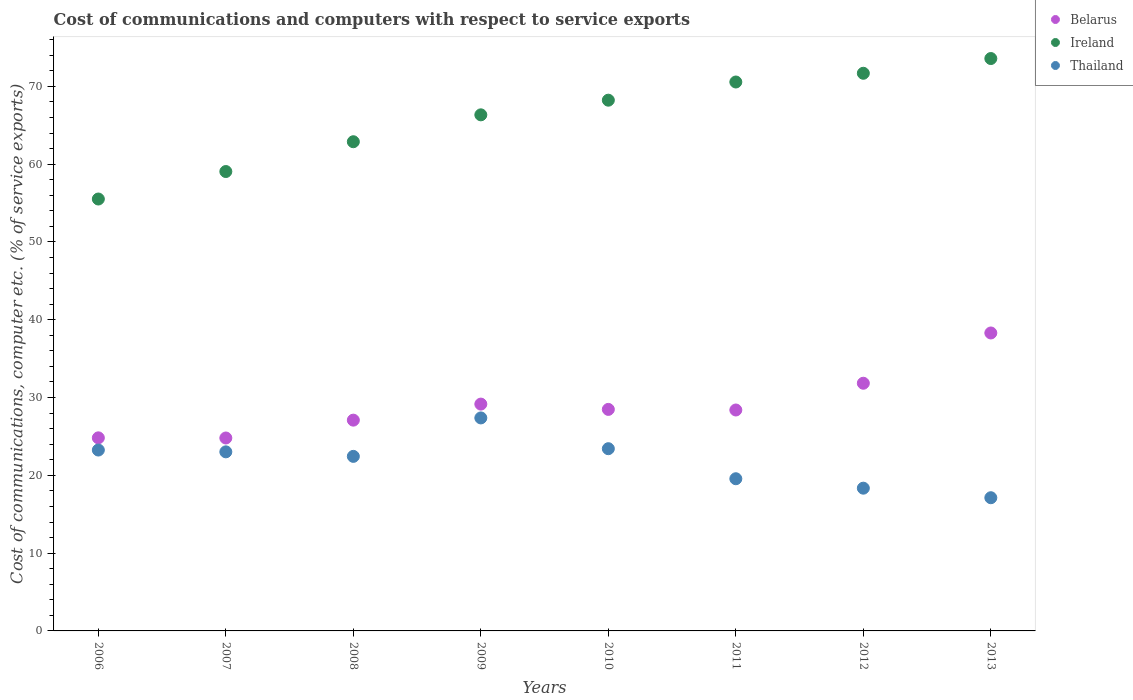What is the cost of communications and computers in Thailand in 2012?
Your answer should be very brief. 18.35. Across all years, what is the maximum cost of communications and computers in Thailand?
Give a very brief answer. 27.38. Across all years, what is the minimum cost of communications and computers in Thailand?
Provide a succinct answer. 17.12. In which year was the cost of communications and computers in Ireland maximum?
Keep it short and to the point. 2013. In which year was the cost of communications and computers in Thailand minimum?
Your answer should be very brief. 2013. What is the total cost of communications and computers in Belarus in the graph?
Give a very brief answer. 232.87. What is the difference between the cost of communications and computers in Ireland in 2006 and that in 2010?
Ensure brevity in your answer.  -12.7. What is the difference between the cost of communications and computers in Belarus in 2008 and the cost of communications and computers in Ireland in 2007?
Ensure brevity in your answer.  -31.96. What is the average cost of communications and computers in Ireland per year?
Your answer should be compact. 65.98. In the year 2011, what is the difference between the cost of communications and computers in Thailand and cost of communications and computers in Ireland?
Offer a very short reply. -50.99. What is the ratio of the cost of communications and computers in Ireland in 2012 to that in 2013?
Keep it short and to the point. 0.97. Is the cost of communications and computers in Belarus in 2008 less than that in 2011?
Provide a short and direct response. Yes. What is the difference between the highest and the second highest cost of communications and computers in Thailand?
Provide a succinct answer. 3.96. What is the difference between the highest and the lowest cost of communications and computers in Thailand?
Make the answer very short. 10.26. In how many years, is the cost of communications and computers in Thailand greater than the average cost of communications and computers in Thailand taken over all years?
Offer a very short reply. 5. Is the sum of the cost of communications and computers in Belarus in 2007 and 2012 greater than the maximum cost of communications and computers in Thailand across all years?
Provide a short and direct response. Yes. Is the cost of communications and computers in Belarus strictly less than the cost of communications and computers in Ireland over the years?
Offer a very short reply. Yes. How many years are there in the graph?
Ensure brevity in your answer.  8. Are the values on the major ticks of Y-axis written in scientific E-notation?
Make the answer very short. No. Does the graph contain any zero values?
Make the answer very short. No. Does the graph contain grids?
Make the answer very short. No. Where does the legend appear in the graph?
Your answer should be very brief. Top right. How many legend labels are there?
Your answer should be compact. 3. What is the title of the graph?
Ensure brevity in your answer.  Cost of communications and computers with respect to service exports. What is the label or title of the X-axis?
Keep it short and to the point. Years. What is the label or title of the Y-axis?
Offer a very short reply. Cost of communications, computer etc. (% of service exports). What is the Cost of communications, computer etc. (% of service exports) of Belarus in 2006?
Offer a terse response. 24.82. What is the Cost of communications, computer etc. (% of service exports) of Ireland in 2006?
Your answer should be compact. 55.52. What is the Cost of communications, computer etc. (% of service exports) of Thailand in 2006?
Make the answer very short. 23.25. What is the Cost of communications, computer etc. (% of service exports) of Belarus in 2007?
Offer a very short reply. 24.8. What is the Cost of communications, computer etc. (% of service exports) in Ireland in 2007?
Ensure brevity in your answer.  59.05. What is the Cost of communications, computer etc. (% of service exports) in Thailand in 2007?
Provide a succinct answer. 23.02. What is the Cost of communications, computer etc. (% of service exports) of Belarus in 2008?
Give a very brief answer. 27.09. What is the Cost of communications, computer etc. (% of service exports) in Ireland in 2008?
Offer a terse response. 62.88. What is the Cost of communications, computer etc. (% of service exports) of Thailand in 2008?
Keep it short and to the point. 22.44. What is the Cost of communications, computer etc. (% of service exports) in Belarus in 2009?
Your answer should be compact. 29.16. What is the Cost of communications, computer etc. (% of service exports) in Ireland in 2009?
Provide a short and direct response. 66.34. What is the Cost of communications, computer etc. (% of service exports) in Thailand in 2009?
Give a very brief answer. 27.38. What is the Cost of communications, computer etc. (% of service exports) of Belarus in 2010?
Provide a short and direct response. 28.47. What is the Cost of communications, computer etc. (% of service exports) of Ireland in 2010?
Provide a succinct answer. 68.22. What is the Cost of communications, computer etc. (% of service exports) of Thailand in 2010?
Make the answer very short. 23.42. What is the Cost of communications, computer etc. (% of service exports) of Belarus in 2011?
Offer a terse response. 28.4. What is the Cost of communications, computer etc. (% of service exports) of Ireland in 2011?
Your answer should be very brief. 70.56. What is the Cost of communications, computer etc. (% of service exports) of Thailand in 2011?
Provide a succinct answer. 19.56. What is the Cost of communications, computer etc. (% of service exports) in Belarus in 2012?
Give a very brief answer. 31.84. What is the Cost of communications, computer etc. (% of service exports) in Ireland in 2012?
Ensure brevity in your answer.  71.68. What is the Cost of communications, computer etc. (% of service exports) of Thailand in 2012?
Give a very brief answer. 18.35. What is the Cost of communications, computer etc. (% of service exports) in Belarus in 2013?
Provide a succinct answer. 38.3. What is the Cost of communications, computer etc. (% of service exports) in Ireland in 2013?
Your response must be concise. 73.57. What is the Cost of communications, computer etc. (% of service exports) in Thailand in 2013?
Provide a short and direct response. 17.12. Across all years, what is the maximum Cost of communications, computer etc. (% of service exports) in Belarus?
Ensure brevity in your answer.  38.3. Across all years, what is the maximum Cost of communications, computer etc. (% of service exports) of Ireland?
Your answer should be compact. 73.57. Across all years, what is the maximum Cost of communications, computer etc. (% of service exports) in Thailand?
Your answer should be very brief. 27.38. Across all years, what is the minimum Cost of communications, computer etc. (% of service exports) of Belarus?
Offer a terse response. 24.8. Across all years, what is the minimum Cost of communications, computer etc. (% of service exports) in Ireland?
Your answer should be very brief. 55.52. Across all years, what is the minimum Cost of communications, computer etc. (% of service exports) of Thailand?
Make the answer very short. 17.12. What is the total Cost of communications, computer etc. (% of service exports) of Belarus in the graph?
Make the answer very short. 232.87. What is the total Cost of communications, computer etc. (% of service exports) of Ireland in the graph?
Offer a very short reply. 527.8. What is the total Cost of communications, computer etc. (% of service exports) in Thailand in the graph?
Your answer should be very brief. 174.53. What is the difference between the Cost of communications, computer etc. (% of service exports) of Belarus in 2006 and that in 2007?
Give a very brief answer. 0.02. What is the difference between the Cost of communications, computer etc. (% of service exports) of Ireland in 2006 and that in 2007?
Offer a terse response. -3.53. What is the difference between the Cost of communications, computer etc. (% of service exports) in Thailand in 2006 and that in 2007?
Your answer should be compact. 0.23. What is the difference between the Cost of communications, computer etc. (% of service exports) in Belarus in 2006 and that in 2008?
Offer a terse response. -2.27. What is the difference between the Cost of communications, computer etc. (% of service exports) in Ireland in 2006 and that in 2008?
Keep it short and to the point. -7.36. What is the difference between the Cost of communications, computer etc. (% of service exports) of Thailand in 2006 and that in 2008?
Offer a very short reply. 0.81. What is the difference between the Cost of communications, computer etc. (% of service exports) of Belarus in 2006 and that in 2009?
Provide a succinct answer. -4.34. What is the difference between the Cost of communications, computer etc. (% of service exports) in Ireland in 2006 and that in 2009?
Ensure brevity in your answer.  -10.82. What is the difference between the Cost of communications, computer etc. (% of service exports) of Thailand in 2006 and that in 2009?
Your answer should be very brief. -4.13. What is the difference between the Cost of communications, computer etc. (% of service exports) in Belarus in 2006 and that in 2010?
Keep it short and to the point. -3.66. What is the difference between the Cost of communications, computer etc. (% of service exports) in Ireland in 2006 and that in 2010?
Keep it short and to the point. -12.7. What is the difference between the Cost of communications, computer etc. (% of service exports) of Thailand in 2006 and that in 2010?
Provide a succinct answer. -0.17. What is the difference between the Cost of communications, computer etc. (% of service exports) in Belarus in 2006 and that in 2011?
Give a very brief answer. -3.58. What is the difference between the Cost of communications, computer etc. (% of service exports) of Ireland in 2006 and that in 2011?
Offer a very short reply. -15.04. What is the difference between the Cost of communications, computer etc. (% of service exports) of Thailand in 2006 and that in 2011?
Your answer should be very brief. 3.69. What is the difference between the Cost of communications, computer etc. (% of service exports) of Belarus in 2006 and that in 2012?
Your response must be concise. -7.02. What is the difference between the Cost of communications, computer etc. (% of service exports) of Ireland in 2006 and that in 2012?
Provide a succinct answer. -16.16. What is the difference between the Cost of communications, computer etc. (% of service exports) in Thailand in 2006 and that in 2012?
Provide a short and direct response. 4.9. What is the difference between the Cost of communications, computer etc. (% of service exports) in Belarus in 2006 and that in 2013?
Your answer should be very brief. -13.48. What is the difference between the Cost of communications, computer etc. (% of service exports) of Ireland in 2006 and that in 2013?
Offer a terse response. -18.06. What is the difference between the Cost of communications, computer etc. (% of service exports) in Thailand in 2006 and that in 2013?
Offer a terse response. 6.13. What is the difference between the Cost of communications, computer etc. (% of service exports) of Belarus in 2007 and that in 2008?
Ensure brevity in your answer.  -2.29. What is the difference between the Cost of communications, computer etc. (% of service exports) in Ireland in 2007 and that in 2008?
Your answer should be compact. -3.83. What is the difference between the Cost of communications, computer etc. (% of service exports) of Thailand in 2007 and that in 2008?
Provide a short and direct response. 0.58. What is the difference between the Cost of communications, computer etc. (% of service exports) in Belarus in 2007 and that in 2009?
Provide a succinct answer. -4.36. What is the difference between the Cost of communications, computer etc. (% of service exports) in Ireland in 2007 and that in 2009?
Ensure brevity in your answer.  -7.29. What is the difference between the Cost of communications, computer etc. (% of service exports) of Thailand in 2007 and that in 2009?
Offer a very short reply. -4.36. What is the difference between the Cost of communications, computer etc. (% of service exports) of Belarus in 2007 and that in 2010?
Your answer should be very brief. -3.68. What is the difference between the Cost of communications, computer etc. (% of service exports) in Ireland in 2007 and that in 2010?
Provide a succinct answer. -9.17. What is the difference between the Cost of communications, computer etc. (% of service exports) of Thailand in 2007 and that in 2010?
Give a very brief answer. -0.4. What is the difference between the Cost of communications, computer etc. (% of service exports) of Belarus in 2007 and that in 2011?
Ensure brevity in your answer.  -3.6. What is the difference between the Cost of communications, computer etc. (% of service exports) in Ireland in 2007 and that in 2011?
Offer a terse response. -11.51. What is the difference between the Cost of communications, computer etc. (% of service exports) of Thailand in 2007 and that in 2011?
Offer a terse response. 3.46. What is the difference between the Cost of communications, computer etc. (% of service exports) in Belarus in 2007 and that in 2012?
Make the answer very short. -7.04. What is the difference between the Cost of communications, computer etc. (% of service exports) of Ireland in 2007 and that in 2012?
Your answer should be compact. -12.63. What is the difference between the Cost of communications, computer etc. (% of service exports) in Thailand in 2007 and that in 2012?
Provide a succinct answer. 4.67. What is the difference between the Cost of communications, computer etc. (% of service exports) in Belarus in 2007 and that in 2013?
Provide a short and direct response. -13.5. What is the difference between the Cost of communications, computer etc. (% of service exports) in Ireland in 2007 and that in 2013?
Ensure brevity in your answer.  -14.52. What is the difference between the Cost of communications, computer etc. (% of service exports) of Thailand in 2007 and that in 2013?
Keep it short and to the point. 5.9. What is the difference between the Cost of communications, computer etc. (% of service exports) of Belarus in 2008 and that in 2009?
Offer a very short reply. -2.06. What is the difference between the Cost of communications, computer etc. (% of service exports) in Ireland in 2008 and that in 2009?
Make the answer very short. -3.46. What is the difference between the Cost of communications, computer etc. (% of service exports) in Thailand in 2008 and that in 2009?
Ensure brevity in your answer.  -4.94. What is the difference between the Cost of communications, computer etc. (% of service exports) in Belarus in 2008 and that in 2010?
Provide a succinct answer. -1.38. What is the difference between the Cost of communications, computer etc. (% of service exports) of Ireland in 2008 and that in 2010?
Offer a very short reply. -5.34. What is the difference between the Cost of communications, computer etc. (% of service exports) of Thailand in 2008 and that in 2010?
Ensure brevity in your answer.  -0.99. What is the difference between the Cost of communications, computer etc. (% of service exports) of Belarus in 2008 and that in 2011?
Give a very brief answer. -1.3. What is the difference between the Cost of communications, computer etc. (% of service exports) in Ireland in 2008 and that in 2011?
Make the answer very short. -7.68. What is the difference between the Cost of communications, computer etc. (% of service exports) in Thailand in 2008 and that in 2011?
Your response must be concise. 2.87. What is the difference between the Cost of communications, computer etc. (% of service exports) in Belarus in 2008 and that in 2012?
Offer a terse response. -4.74. What is the difference between the Cost of communications, computer etc. (% of service exports) of Ireland in 2008 and that in 2012?
Offer a very short reply. -8.8. What is the difference between the Cost of communications, computer etc. (% of service exports) of Thailand in 2008 and that in 2012?
Your response must be concise. 4.09. What is the difference between the Cost of communications, computer etc. (% of service exports) in Belarus in 2008 and that in 2013?
Provide a succinct answer. -11.2. What is the difference between the Cost of communications, computer etc. (% of service exports) of Ireland in 2008 and that in 2013?
Your answer should be very brief. -10.69. What is the difference between the Cost of communications, computer etc. (% of service exports) of Thailand in 2008 and that in 2013?
Provide a short and direct response. 5.32. What is the difference between the Cost of communications, computer etc. (% of service exports) of Belarus in 2009 and that in 2010?
Your answer should be very brief. 0.68. What is the difference between the Cost of communications, computer etc. (% of service exports) of Ireland in 2009 and that in 2010?
Your answer should be very brief. -1.88. What is the difference between the Cost of communications, computer etc. (% of service exports) of Thailand in 2009 and that in 2010?
Your answer should be very brief. 3.96. What is the difference between the Cost of communications, computer etc. (% of service exports) of Belarus in 2009 and that in 2011?
Offer a terse response. 0.76. What is the difference between the Cost of communications, computer etc. (% of service exports) in Ireland in 2009 and that in 2011?
Offer a very short reply. -4.22. What is the difference between the Cost of communications, computer etc. (% of service exports) in Thailand in 2009 and that in 2011?
Your answer should be compact. 7.82. What is the difference between the Cost of communications, computer etc. (% of service exports) of Belarus in 2009 and that in 2012?
Offer a very short reply. -2.68. What is the difference between the Cost of communications, computer etc. (% of service exports) of Ireland in 2009 and that in 2012?
Offer a very short reply. -5.34. What is the difference between the Cost of communications, computer etc. (% of service exports) of Thailand in 2009 and that in 2012?
Your answer should be compact. 9.03. What is the difference between the Cost of communications, computer etc. (% of service exports) in Belarus in 2009 and that in 2013?
Provide a short and direct response. -9.14. What is the difference between the Cost of communications, computer etc. (% of service exports) of Ireland in 2009 and that in 2013?
Ensure brevity in your answer.  -7.24. What is the difference between the Cost of communications, computer etc. (% of service exports) of Thailand in 2009 and that in 2013?
Offer a very short reply. 10.26. What is the difference between the Cost of communications, computer etc. (% of service exports) of Belarus in 2010 and that in 2011?
Keep it short and to the point. 0.08. What is the difference between the Cost of communications, computer etc. (% of service exports) in Ireland in 2010 and that in 2011?
Provide a short and direct response. -2.34. What is the difference between the Cost of communications, computer etc. (% of service exports) of Thailand in 2010 and that in 2011?
Provide a succinct answer. 3.86. What is the difference between the Cost of communications, computer etc. (% of service exports) of Belarus in 2010 and that in 2012?
Give a very brief answer. -3.36. What is the difference between the Cost of communications, computer etc. (% of service exports) of Ireland in 2010 and that in 2012?
Your response must be concise. -3.46. What is the difference between the Cost of communications, computer etc. (% of service exports) of Thailand in 2010 and that in 2012?
Your answer should be compact. 5.07. What is the difference between the Cost of communications, computer etc. (% of service exports) in Belarus in 2010 and that in 2013?
Your response must be concise. -9.82. What is the difference between the Cost of communications, computer etc. (% of service exports) of Ireland in 2010 and that in 2013?
Ensure brevity in your answer.  -5.35. What is the difference between the Cost of communications, computer etc. (% of service exports) of Thailand in 2010 and that in 2013?
Provide a succinct answer. 6.3. What is the difference between the Cost of communications, computer etc. (% of service exports) in Belarus in 2011 and that in 2012?
Your answer should be compact. -3.44. What is the difference between the Cost of communications, computer etc. (% of service exports) of Ireland in 2011 and that in 2012?
Provide a succinct answer. -1.12. What is the difference between the Cost of communications, computer etc. (% of service exports) in Thailand in 2011 and that in 2012?
Provide a succinct answer. 1.21. What is the difference between the Cost of communications, computer etc. (% of service exports) of Belarus in 2011 and that in 2013?
Offer a very short reply. -9.9. What is the difference between the Cost of communications, computer etc. (% of service exports) in Ireland in 2011 and that in 2013?
Offer a terse response. -3.02. What is the difference between the Cost of communications, computer etc. (% of service exports) in Thailand in 2011 and that in 2013?
Offer a very short reply. 2.44. What is the difference between the Cost of communications, computer etc. (% of service exports) in Belarus in 2012 and that in 2013?
Make the answer very short. -6.46. What is the difference between the Cost of communications, computer etc. (% of service exports) of Ireland in 2012 and that in 2013?
Your answer should be very brief. -1.89. What is the difference between the Cost of communications, computer etc. (% of service exports) in Thailand in 2012 and that in 2013?
Ensure brevity in your answer.  1.23. What is the difference between the Cost of communications, computer etc. (% of service exports) of Belarus in 2006 and the Cost of communications, computer etc. (% of service exports) of Ireland in 2007?
Offer a terse response. -34.23. What is the difference between the Cost of communications, computer etc. (% of service exports) of Belarus in 2006 and the Cost of communications, computer etc. (% of service exports) of Thailand in 2007?
Provide a short and direct response. 1.8. What is the difference between the Cost of communications, computer etc. (% of service exports) in Ireland in 2006 and the Cost of communications, computer etc. (% of service exports) in Thailand in 2007?
Ensure brevity in your answer.  32.5. What is the difference between the Cost of communications, computer etc. (% of service exports) in Belarus in 2006 and the Cost of communications, computer etc. (% of service exports) in Ireland in 2008?
Your response must be concise. -38.06. What is the difference between the Cost of communications, computer etc. (% of service exports) in Belarus in 2006 and the Cost of communications, computer etc. (% of service exports) in Thailand in 2008?
Your answer should be very brief. 2.38. What is the difference between the Cost of communications, computer etc. (% of service exports) of Ireland in 2006 and the Cost of communications, computer etc. (% of service exports) of Thailand in 2008?
Keep it short and to the point. 33.08. What is the difference between the Cost of communications, computer etc. (% of service exports) in Belarus in 2006 and the Cost of communications, computer etc. (% of service exports) in Ireland in 2009?
Give a very brief answer. -41.52. What is the difference between the Cost of communications, computer etc. (% of service exports) in Belarus in 2006 and the Cost of communications, computer etc. (% of service exports) in Thailand in 2009?
Your answer should be very brief. -2.56. What is the difference between the Cost of communications, computer etc. (% of service exports) of Ireland in 2006 and the Cost of communications, computer etc. (% of service exports) of Thailand in 2009?
Provide a short and direct response. 28.14. What is the difference between the Cost of communications, computer etc. (% of service exports) in Belarus in 2006 and the Cost of communications, computer etc. (% of service exports) in Ireland in 2010?
Your response must be concise. -43.4. What is the difference between the Cost of communications, computer etc. (% of service exports) in Belarus in 2006 and the Cost of communications, computer etc. (% of service exports) in Thailand in 2010?
Give a very brief answer. 1.4. What is the difference between the Cost of communications, computer etc. (% of service exports) in Ireland in 2006 and the Cost of communications, computer etc. (% of service exports) in Thailand in 2010?
Provide a short and direct response. 32.09. What is the difference between the Cost of communications, computer etc. (% of service exports) of Belarus in 2006 and the Cost of communications, computer etc. (% of service exports) of Ireland in 2011?
Provide a short and direct response. -45.74. What is the difference between the Cost of communications, computer etc. (% of service exports) of Belarus in 2006 and the Cost of communications, computer etc. (% of service exports) of Thailand in 2011?
Your response must be concise. 5.26. What is the difference between the Cost of communications, computer etc. (% of service exports) of Ireland in 2006 and the Cost of communications, computer etc. (% of service exports) of Thailand in 2011?
Your answer should be compact. 35.95. What is the difference between the Cost of communications, computer etc. (% of service exports) of Belarus in 2006 and the Cost of communications, computer etc. (% of service exports) of Ireland in 2012?
Provide a short and direct response. -46.86. What is the difference between the Cost of communications, computer etc. (% of service exports) of Belarus in 2006 and the Cost of communications, computer etc. (% of service exports) of Thailand in 2012?
Give a very brief answer. 6.47. What is the difference between the Cost of communications, computer etc. (% of service exports) in Ireland in 2006 and the Cost of communications, computer etc. (% of service exports) in Thailand in 2012?
Make the answer very short. 37.17. What is the difference between the Cost of communications, computer etc. (% of service exports) in Belarus in 2006 and the Cost of communications, computer etc. (% of service exports) in Ireland in 2013?
Offer a terse response. -48.75. What is the difference between the Cost of communications, computer etc. (% of service exports) of Belarus in 2006 and the Cost of communications, computer etc. (% of service exports) of Thailand in 2013?
Provide a short and direct response. 7.7. What is the difference between the Cost of communications, computer etc. (% of service exports) of Ireland in 2006 and the Cost of communications, computer etc. (% of service exports) of Thailand in 2013?
Your answer should be very brief. 38.39. What is the difference between the Cost of communications, computer etc. (% of service exports) in Belarus in 2007 and the Cost of communications, computer etc. (% of service exports) in Ireland in 2008?
Provide a short and direct response. -38.08. What is the difference between the Cost of communications, computer etc. (% of service exports) in Belarus in 2007 and the Cost of communications, computer etc. (% of service exports) in Thailand in 2008?
Your response must be concise. 2.36. What is the difference between the Cost of communications, computer etc. (% of service exports) of Ireland in 2007 and the Cost of communications, computer etc. (% of service exports) of Thailand in 2008?
Provide a short and direct response. 36.61. What is the difference between the Cost of communications, computer etc. (% of service exports) in Belarus in 2007 and the Cost of communications, computer etc. (% of service exports) in Ireland in 2009?
Provide a succinct answer. -41.54. What is the difference between the Cost of communications, computer etc. (% of service exports) of Belarus in 2007 and the Cost of communications, computer etc. (% of service exports) of Thailand in 2009?
Your answer should be compact. -2.58. What is the difference between the Cost of communications, computer etc. (% of service exports) in Ireland in 2007 and the Cost of communications, computer etc. (% of service exports) in Thailand in 2009?
Keep it short and to the point. 31.67. What is the difference between the Cost of communications, computer etc. (% of service exports) of Belarus in 2007 and the Cost of communications, computer etc. (% of service exports) of Ireland in 2010?
Give a very brief answer. -43.42. What is the difference between the Cost of communications, computer etc. (% of service exports) in Belarus in 2007 and the Cost of communications, computer etc. (% of service exports) in Thailand in 2010?
Your answer should be very brief. 1.38. What is the difference between the Cost of communications, computer etc. (% of service exports) in Ireland in 2007 and the Cost of communications, computer etc. (% of service exports) in Thailand in 2010?
Give a very brief answer. 35.63. What is the difference between the Cost of communications, computer etc. (% of service exports) in Belarus in 2007 and the Cost of communications, computer etc. (% of service exports) in Ireland in 2011?
Provide a succinct answer. -45.76. What is the difference between the Cost of communications, computer etc. (% of service exports) in Belarus in 2007 and the Cost of communications, computer etc. (% of service exports) in Thailand in 2011?
Your answer should be compact. 5.24. What is the difference between the Cost of communications, computer etc. (% of service exports) of Ireland in 2007 and the Cost of communications, computer etc. (% of service exports) of Thailand in 2011?
Offer a very short reply. 39.49. What is the difference between the Cost of communications, computer etc. (% of service exports) in Belarus in 2007 and the Cost of communications, computer etc. (% of service exports) in Ireland in 2012?
Your response must be concise. -46.88. What is the difference between the Cost of communications, computer etc. (% of service exports) in Belarus in 2007 and the Cost of communications, computer etc. (% of service exports) in Thailand in 2012?
Make the answer very short. 6.45. What is the difference between the Cost of communications, computer etc. (% of service exports) in Ireland in 2007 and the Cost of communications, computer etc. (% of service exports) in Thailand in 2012?
Your response must be concise. 40.7. What is the difference between the Cost of communications, computer etc. (% of service exports) in Belarus in 2007 and the Cost of communications, computer etc. (% of service exports) in Ireland in 2013?
Offer a very short reply. -48.77. What is the difference between the Cost of communications, computer etc. (% of service exports) in Belarus in 2007 and the Cost of communications, computer etc. (% of service exports) in Thailand in 2013?
Your answer should be very brief. 7.68. What is the difference between the Cost of communications, computer etc. (% of service exports) in Ireland in 2007 and the Cost of communications, computer etc. (% of service exports) in Thailand in 2013?
Ensure brevity in your answer.  41.93. What is the difference between the Cost of communications, computer etc. (% of service exports) in Belarus in 2008 and the Cost of communications, computer etc. (% of service exports) in Ireland in 2009?
Offer a terse response. -39.24. What is the difference between the Cost of communications, computer etc. (% of service exports) in Belarus in 2008 and the Cost of communications, computer etc. (% of service exports) in Thailand in 2009?
Ensure brevity in your answer.  -0.29. What is the difference between the Cost of communications, computer etc. (% of service exports) of Ireland in 2008 and the Cost of communications, computer etc. (% of service exports) of Thailand in 2009?
Make the answer very short. 35.5. What is the difference between the Cost of communications, computer etc. (% of service exports) in Belarus in 2008 and the Cost of communications, computer etc. (% of service exports) in Ireland in 2010?
Provide a short and direct response. -41.13. What is the difference between the Cost of communications, computer etc. (% of service exports) of Belarus in 2008 and the Cost of communications, computer etc. (% of service exports) of Thailand in 2010?
Your answer should be compact. 3.67. What is the difference between the Cost of communications, computer etc. (% of service exports) of Ireland in 2008 and the Cost of communications, computer etc. (% of service exports) of Thailand in 2010?
Your response must be concise. 39.46. What is the difference between the Cost of communications, computer etc. (% of service exports) of Belarus in 2008 and the Cost of communications, computer etc. (% of service exports) of Ireland in 2011?
Give a very brief answer. -43.46. What is the difference between the Cost of communications, computer etc. (% of service exports) of Belarus in 2008 and the Cost of communications, computer etc. (% of service exports) of Thailand in 2011?
Provide a short and direct response. 7.53. What is the difference between the Cost of communications, computer etc. (% of service exports) of Ireland in 2008 and the Cost of communications, computer etc. (% of service exports) of Thailand in 2011?
Your answer should be very brief. 43.32. What is the difference between the Cost of communications, computer etc. (% of service exports) in Belarus in 2008 and the Cost of communications, computer etc. (% of service exports) in Ireland in 2012?
Your answer should be very brief. -44.59. What is the difference between the Cost of communications, computer etc. (% of service exports) of Belarus in 2008 and the Cost of communications, computer etc. (% of service exports) of Thailand in 2012?
Ensure brevity in your answer.  8.75. What is the difference between the Cost of communications, computer etc. (% of service exports) in Ireland in 2008 and the Cost of communications, computer etc. (% of service exports) in Thailand in 2012?
Give a very brief answer. 44.53. What is the difference between the Cost of communications, computer etc. (% of service exports) of Belarus in 2008 and the Cost of communications, computer etc. (% of service exports) of Ireland in 2013?
Offer a terse response. -46.48. What is the difference between the Cost of communications, computer etc. (% of service exports) of Belarus in 2008 and the Cost of communications, computer etc. (% of service exports) of Thailand in 2013?
Provide a short and direct response. 9.97. What is the difference between the Cost of communications, computer etc. (% of service exports) in Ireland in 2008 and the Cost of communications, computer etc. (% of service exports) in Thailand in 2013?
Make the answer very short. 45.76. What is the difference between the Cost of communications, computer etc. (% of service exports) in Belarus in 2009 and the Cost of communications, computer etc. (% of service exports) in Ireland in 2010?
Give a very brief answer. -39.06. What is the difference between the Cost of communications, computer etc. (% of service exports) of Belarus in 2009 and the Cost of communications, computer etc. (% of service exports) of Thailand in 2010?
Keep it short and to the point. 5.73. What is the difference between the Cost of communications, computer etc. (% of service exports) of Ireland in 2009 and the Cost of communications, computer etc. (% of service exports) of Thailand in 2010?
Make the answer very short. 42.91. What is the difference between the Cost of communications, computer etc. (% of service exports) in Belarus in 2009 and the Cost of communications, computer etc. (% of service exports) in Ireland in 2011?
Your answer should be very brief. -41.4. What is the difference between the Cost of communications, computer etc. (% of service exports) in Belarus in 2009 and the Cost of communications, computer etc. (% of service exports) in Thailand in 2011?
Your answer should be compact. 9.59. What is the difference between the Cost of communications, computer etc. (% of service exports) in Ireland in 2009 and the Cost of communications, computer etc. (% of service exports) in Thailand in 2011?
Provide a short and direct response. 46.77. What is the difference between the Cost of communications, computer etc. (% of service exports) of Belarus in 2009 and the Cost of communications, computer etc. (% of service exports) of Ireland in 2012?
Give a very brief answer. -42.52. What is the difference between the Cost of communications, computer etc. (% of service exports) in Belarus in 2009 and the Cost of communications, computer etc. (% of service exports) in Thailand in 2012?
Your answer should be compact. 10.81. What is the difference between the Cost of communications, computer etc. (% of service exports) in Ireland in 2009 and the Cost of communications, computer etc. (% of service exports) in Thailand in 2012?
Make the answer very short. 47.99. What is the difference between the Cost of communications, computer etc. (% of service exports) of Belarus in 2009 and the Cost of communications, computer etc. (% of service exports) of Ireland in 2013?
Make the answer very short. -44.42. What is the difference between the Cost of communications, computer etc. (% of service exports) in Belarus in 2009 and the Cost of communications, computer etc. (% of service exports) in Thailand in 2013?
Offer a terse response. 12.03. What is the difference between the Cost of communications, computer etc. (% of service exports) in Ireland in 2009 and the Cost of communications, computer etc. (% of service exports) in Thailand in 2013?
Offer a terse response. 49.21. What is the difference between the Cost of communications, computer etc. (% of service exports) of Belarus in 2010 and the Cost of communications, computer etc. (% of service exports) of Ireland in 2011?
Ensure brevity in your answer.  -42.08. What is the difference between the Cost of communications, computer etc. (% of service exports) in Belarus in 2010 and the Cost of communications, computer etc. (% of service exports) in Thailand in 2011?
Give a very brief answer. 8.91. What is the difference between the Cost of communications, computer etc. (% of service exports) of Ireland in 2010 and the Cost of communications, computer etc. (% of service exports) of Thailand in 2011?
Provide a short and direct response. 48.66. What is the difference between the Cost of communications, computer etc. (% of service exports) in Belarus in 2010 and the Cost of communications, computer etc. (% of service exports) in Ireland in 2012?
Provide a short and direct response. -43.2. What is the difference between the Cost of communications, computer etc. (% of service exports) in Belarus in 2010 and the Cost of communications, computer etc. (% of service exports) in Thailand in 2012?
Your answer should be compact. 10.13. What is the difference between the Cost of communications, computer etc. (% of service exports) of Ireland in 2010 and the Cost of communications, computer etc. (% of service exports) of Thailand in 2012?
Provide a short and direct response. 49.87. What is the difference between the Cost of communications, computer etc. (% of service exports) in Belarus in 2010 and the Cost of communications, computer etc. (% of service exports) in Ireland in 2013?
Keep it short and to the point. -45.1. What is the difference between the Cost of communications, computer etc. (% of service exports) of Belarus in 2010 and the Cost of communications, computer etc. (% of service exports) of Thailand in 2013?
Give a very brief answer. 11.35. What is the difference between the Cost of communications, computer etc. (% of service exports) of Ireland in 2010 and the Cost of communications, computer etc. (% of service exports) of Thailand in 2013?
Ensure brevity in your answer.  51.1. What is the difference between the Cost of communications, computer etc. (% of service exports) in Belarus in 2011 and the Cost of communications, computer etc. (% of service exports) in Ireland in 2012?
Provide a short and direct response. -43.28. What is the difference between the Cost of communications, computer etc. (% of service exports) in Belarus in 2011 and the Cost of communications, computer etc. (% of service exports) in Thailand in 2012?
Offer a terse response. 10.05. What is the difference between the Cost of communications, computer etc. (% of service exports) in Ireland in 2011 and the Cost of communications, computer etc. (% of service exports) in Thailand in 2012?
Give a very brief answer. 52.21. What is the difference between the Cost of communications, computer etc. (% of service exports) of Belarus in 2011 and the Cost of communications, computer etc. (% of service exports) of Ireland in 2013?
Offer a terse response. -45.18. What is the difference between the Cost of communications, computer etc. (% of service exports) in Belarus in 2011 and the Cost of communications, computer etc. (% of service exports) in Thailand in 2013?
Provide a succinct answer. 11.28. What is the difference between the Cost of communications, computer etc. (% of service exports) in Ireland in 2011 and the Cost of communications, computer etc. (% of service exports) in Thailand in 2013?
Your answer should be very brief. 53.44. What is the difference between the Cost of communications, computer etc. (% of service exports) of Belarus in 2012 and the Cost of communications, computer etc. (% of service exports) of Ireland in 2013?
Keep it short and to the point. -41.74. What is the difference between the Cost of communications, computer etc. (% of service exports) in Belarus in 2012 and the Cost of communications, computer etc. (% of service exports) in Thailand in 2013?
Your response must be concise. 14.72. What is the difference between the Cost of communications, computer etc. (% of service exports) in Ireland in 2012 and the Cost of communications, computer etc. (% of service exports) in Thailand in 2013?
Offer a very short reply. 54.56. What is the average Cost of communications, computer etc. (% of service exports) of Belarus per year?
Give a very brief answer. 29.11. What is the average Cost of communications, computer etc. (% of service exports) in Ireland per year?
Offer a very short reply. 65.98. What is the average Cost of communications, computer etc. (% of service exports) of Thailand per year?
Make the answer very short. 21.82. In the year 2006, what is the difference between the Cost of communications, computer etc. (% of service exports) in Belarus and Cost of communications, computer etc. (% of service exports) in Ireland?
Offer a very short reply. -30.7. In the year 2006, what is the difference between the Cost of communications, computer etc. (% of service exports) in Belarus and Cost of communications, computer etc. (% of service exports) in Thailand?
Your answer should be compact. 1.57. In the year 2006, what is the difference between the Cost of communications, computer etc. (% of service exports) in Ireland and Cost of communications, computer etc. (% of service exports) in Thailand?
Your response must be concise. 32.27. In the year 2007, what is the difference between the Cost of communications, computer etc. (% of service exports) of Belarus and Cost of communications, computer etc. (% of service exports) of Ireland?
Provide a short and direct response. -34.25. In the year 2007, what is the difference between the Cost of communications, computer etc. (% of service exports) of Belarus and Cost of communications, computer etc. (% of service exports) of Thailand?
Your answer should be very brief. 1.78. In the year 2007, what is the difference between the Cost of communications, computer etc. (% of service exports) of Ireland and Cost of communications, computer etc. (% of service exports) of Thailand?
Provide a short and direct response. 36.03. In the year 2008, what is the difference between the Cost of communications, computer etc. (% of service exports) of Belarus and Cost of communications, computer etc. (% of service exports) of Ireland?
Offer a terse response. -35.79. In the year 2008, what is the difference between the Cost of communications, computer etc. (% of service exports) in Belarus and Cost of communications, computer etc. (% of service exports) in Thailand?
Offer a very short reply. 4.66. In the year 2008, what is the difference between the Cost of communications, computer etc. (% of service exports) in Ireland and Cost of communications, computer etc. (% of service exports) in Thailand?
Offer a very short reply. 40.44. In the year 2009, what is the difference between the Cost of communications, computer etc. (% of service exports) in Belarus and Cost of communications, computer etc. (% of service exports) in Ireland?
Provide a short and direct response. -37.18. In the year 2009, what is the difference between the Cost of communications, computer etc. (% of service exports) in Belarus and Cost of communications, computer etc. (% of service exports) in Thailand?
Your answer should be compact. 1.78. In the year 2009, what is the difference between the Cost of communications, computer etc. (% of service exports) of Ireland and Cost of communications, computer etc. (% of service exports) of Thailand?
Your answer should be compact. 38.96. In the year 2010, what is the difference between the Cost of communications, computer etc. (% of service exports) of Belarus and Cost of communications, computer etc. (% of service exports) of Ireland?
Your answer should be very brief. -39.74. In the year 2010, what is the difference between the Cost of communications, computer etc. (% of service exports) of Belarus and Cost of communications, computer etc. (% of service exports) of Thailand?
Your answer should be very brief. 5.05. In the year 2010, what is the difference between the Cost of communications, computer etc. (% of service exports) of Ireland and Cost of communications, computer etc. (% of service exports) of Thailand?
Offer a very short reply. 44.8. In the year 2011, what is the difference between the Cost of communications, computer etc. (% of service exports) in Belarus and Cost of communications, computer etc. (% of service exports) in Ireland?
Your answer should be compact. -42.16. In the year 2011, what is the difference between the Cost of communications, computer etc. (% of service exports) in Belarus and Cost of communications, computer etc. (% of service exports) in Thailand?
Make the answer very short. 8.84. In the year 2011, what is the difference between the Cost of communications, computer etc. (% of service exports) in Ireland and Cost of communications, computer etc. (% of service exports) in Thailand?
Provide a short and direct response. 50.99. In the year 2012, what is the difference between the Cost of communications, computer etc. (% of service exports) in Belarus and Cost of communications, computer etc. (% of service exports) in Ireland?
Offer a terse response. -39.84. In the year 2012, what is the difference between the Cost of communications, computer etc. (% of service exports) in Belarus and Cost of communications, computer etc. (% of service exports) in Thailand?
Provide a short and direct response. 13.49. In the year 2012, what is the difference between the Cost of communications, computer etc. (% of service exports) in Ireland and Cost of communications, computer etc. (% of service exports) in Thailand?
Your answer should be compact. 53.33. In the year 2013, what is the difference between the Cost of communications, computer etc. (% of service exports) in Belarus and Cost of communications, computer etc. (% of service exports) in Ireland?
Your answer should be compact. -35.28. In the year 2013, what is the difference between the Cost of communications, computer etc. (% of service exports) of Belarus and Cost of communications, computer etc. (% of service exports) of Thailand?
Make the answer very short. 21.18. In the year 2013, what is the difference between the Cost of communications, computer etc. (% of service exports) of Ireland and Cost of communications, computer etc. (% of service exports) of Thailand?
Your response must be concise. 56.45. What is the ratio of the Cost of communications, computer etc. (% of service exports) of Belarus in 2006 to that in 2007?
Provide a succinct answer. 1. What is the ratio of the Cost of communications, computer etc. (% of service exports) of Ireland in 2006 to that in 2007?
Ensure brevity in your answer.  0.94. What is the ratio of the Cost of communications, computer etc. (% of service exports) in Thailand in 2006 to that in 2007?
Provide a short and direct response. 1.01. What is the ratio of the Cost of communications, computer etc. (% of service exports) in Belarus in 2006 to that in 2008?
Keep it short and to the point. 0.92. What is the ratio of the Cost of communications, computer etc. (% of service exports) of Ireland in 2006 to that in 2008?
Offer a very short reply. 0.88. What is the ratio of the Cost of communications, computer etc. (% of service exports) in Thailand in 2006 to that in 2008?
Keep it short and to the point. 1.04. What is the ratio of the Cost of communications, computer etc. (% of service exports) of Belarus in 2006 to that in 2009?
Your answer should be compact. 0.85. What is the ratio of the Cost of communications, computer etc. (% of service exports) in Ireland in 2006 to that in 2009?
Offer a very short reply. 0.84. What is the ratio of the Cost of communications, computer etc. (% of service exports) of Thailand in 2006 to that in 2009?
Keep it short and to the point. 0.85. What is the ratio of the Cost of communications, computer etc. (% of service exports) of Belarus in 2006 to that in 2010?
Make the answer very short. 0.87. What is the ratio of the Cost of communications, computer etc. (% of service exports) in Ireland in 2006 to that in 2010?
Offer a terse response. 0.81. What is the ratio of the Cost of communications, computer etc. (% of service exports) in Thailand in 2006 to that in 2010?
Keep it short and to the point. 0.99. What is the ratio of the Cost of communications, computer etc. (% of service exports) in Belarus in 2006 to that in 2011?
Your answer should be compact. 0.87. What is the ratio of the Cost of communications, computer etc. (% of service exports) of Ireland in 2006 to that in 2011?
Ensure brevity in your answer.  0.79. What is the ratio of the Cost of communications, computer etc. (% of service exports) of Thailand in 2006 to that in 2011?
Offer a terse response. 1.19. What is the ratio of the Cost of communications, computer etc. (% of service exports) of Belarus in 2006 to that in 2012?
Your answer should be very brief. 0.78. What is the ratio of the Cost of communications, computer etc. (% of service exports) of Ireland in 2006 to that in 2012?
Ensure brevity in your answer.  0.77. What is the ratio of the Cost of communications, computer etc. (% of service exports) in Thailand in 2006 to that in 2012?
Make the answer very short. 1.27. What is the ratio of the Cost of communications, computer etc. (% of service exports) of Belarus in 2006 to that in 2013?
Your response must be concise. 0.65. What is the ratio of the Cost of communications, computer etc. (% of service exports) in Ireland in 2006 to that in 2013?
Ensure brevity in your answer.  0.75. What is the ratio of the Cost of communications, computer etc. (% of service exports) in Thailand in 2006 to that in 2013?
Your response must be concise. 1.36. What is the ratio of the Cost of communications, computer etc. (% of service exports) in Belarus in 2007 to that in 2008?
Keep it short and to the point. 0.92. What is the ratio of the Cost of communications, computer etc. (% of service exports) in Ireland in 2007 to that in 2008?
Your response must be concise. 0.94. What is the ratio of the Cost of communications, computer etc. (% of service exports) of Thailand in 2007 to that in 2008?
Ensure brevity in your answer.  1.03. What is the ratio of the Cost of communications, computer etc. (% of service exports) in Belarus in 2007 to that in 2009?
Provide a succinct answer. 0.85. What is the ratio of the Cost of communications, computer etc. (% of service exports) in Ireland in 2007 to that in 2009?
Your answer should be compact. 0.89. What is the ratio of the Cost of communications, computer etc. (% of service exports) of Thailand in 2007 to that in 2009?
Your answer should be compact. 0.84. What is the ratio of the Cost of communications, computer etc. (% of service exports) of Belarus in 2007 to that in 2010?
Your response must be concise. 0.87. What is the ratio of the Cost of communications, computer etc. (% of service exports) of Ireland in 2007 to that in 2010?
Provide a succinct answer. 0.87. What is the ratio of the Cost of communications, computer etc. (% of service exports) of Thailand in 2007 to that in 2010?
Your response must be concise. 0.98. What is the ratio of the Cost of communications, computer etc. (% of service exports) in Belarus in 2007 to that in 2011?
Ensure brevity in your answer.  0.87. What is the ratio of the Cost of communications, computer etc. (% of service exports) in Ireland in 2007 to that in 2011?
Make the answer very short. 0.84. What is the ratio of the Cost of communications, computer etc. (% of service exports) in Thailand in 2007 to that in 2011?
Ensure brevity in your answer.  1.18. What is the ratio of the Cost of communications, computer etc. (% of service exports) in Belarus in 2007 to that in 2012?
Your answer should be very brief. 0.78. What is the ratio of the Cost of communications, computer etc. (% of service exports) of Ireland in 2007 to that in 2012?
Offer a very short reply. 0.82. What is the ratio of the Cost of communications, computer etc. (% of service exports) in Thailand in 2007 to that in 2012?
Your answer should be very brief. 1.25. What is the ratio of the Cost of communications, computer etc. (% of service exports) in Belarus in 2007 to that in 2013?
Your answer should be compact. 0.65. What is the ratio of the Cost of communications, computer etc. (% of service exports) in Ireland in 2007 to that in 2013?
Your response must be concise. 0.8. What is the ratio of the Cost of communications, computer etc. (% of service exports) of Thailand in 2007 to that in 2013?
Make the answer very short. 1.34. What is the ratio of the Cost of communications, computer etc. (% of service exports) in Belarus in 2008 to that in 2009?
Your answer should be very brief. 0.93. What is the ratio of the Cost of communications, computer etc. (% of service exports) in Ireland in 2008 to that in 2009?
Offer a very short reply. 0.95. What is the ratio of the Cost of communications, computer etc. (% of service exports) of Thailand in 2008 to that in 2009?
Give a very brief answer. 0.82. What is the ratio of the Cost of communications, computer etc. (% of service exports) in Belarus in 2008 to that in 2010?
Provide a succinct answer. 0.95. What is the ratio of the Cost of communications, computer etc. (% of service exports) in Ireland in 2008 to that in 2010?
Offer a very short reply. 0.92. What is the ratio of the Cost of communications, computer etc. (% of service exports) of Thailand in 2008 to that in 2010?
Keep it short and to the point. 0.96. What is the ratio of the Cost of communications, computer etc. (% of service exports) in Belarus in 2008 to that in 2011?
Offer a very short reply. 0.95. What is the ratio of the Cost of communications, computer etc. (% of service exports) in Ireland in 2008 to that in 2011?
Your answer should be very brief. 0.89. What is the ratio of the Cost of communications, computer etc. (% of service exports) in Thailand in 2008 to that in 2011?
Provide a succinct answer. 1.15. What is the ratio of the Cost of communications, computer etc. (% of service exports) of Belarus in 2008 to that in 2012?
Offer a terse response. 0.85. What is the ratio of the Cost of communications, computer etc. (% of service exports) of Ireland in 2008 to that in 2012?
Your answer should be very brief. 0.88. What is the ratio of the Cost of communications, computer etc. (% of service exports) of Thailand in 2008 to that in 2012?
Keep it short and to the point. 1.22. What is the ratio of the Cost of communications, computer etc. (% of service exports) of Belarus in 2008 to that in 2013?
Keep it short and to the point. 0.71. What is the ratio of the Cost of communications, computer etc. (% of service exports) in Ireland in 2008 to that in 2013?
Offer a terse response. 0.85. What is the ratio of the Cost of communications, computer etc. (% of service exports) in Thailand in 2008 to that in 2013?
Your answer should be compact. 1.31. What is the ratio of the Cost of communications, computer etc. (% of service exports) of Belarus in 2009 to that in 2010?
Your answer should be very brief. 1.02. What is the ratio of the Cost of communications, computer etc. (% of service exports) of Ireland in 2009 to that in 2010?
Offer a terse response. 0.97. What is the ratio of the Cost of communications, computer etc. (% of service exports) of Thailand in 2009 to that in 2010?
Provide a short and direct response. 1.17. What is the ratio of the Cost of communications, computer etc. (% of service exports) of Belarus in 2009 to that in 2011?
Provide a short and direct response. 1.03. What is the ratio of the Cost of communications, computer etc. (% of service exports) of Ireland in 2009 to that in 2011?
Offer a terse response. 0.94. What is the ratio of the Cost of communications, computer etc. (% of service exports) of Thailand in 2009 to that in 2011?
Offer a terse response. 1.4. What is the ratio of the Cost of communications, computer etc. (% of service exports) in Belarus in 2009 to that in 2012?
Provide a succinct answer. 0.92. What is the ratio of the Cost of communications, computer etc. (% of service exports) of Ireland in 2009 to that in 2012?
Your response must be concise. 0.93. What is the ratio of the Cost of communications, computer etc. (% of service exports) in Thailand in 2009 to that in 2012?
Your answer should be very brief. 1.49. What is the ratio of the Cost of communications, computer etc. (% of service exports) of Belarus in 2009 to that in 2013?
Offer a very short reply. 0.76. What is the ratio of the Cost of communications, computer etc. (% of service exports) in Ireland in 2009 to that in 2013?
Provide a short and direct response. 0.9. What is the ratio of the Cost of communications, computer etc. (% of service exports) in Thailand in 2009 to that in 2013?
Provide a succinct answer. 1.6. What is the ratio of the Cost of communications, computer etc. (% of service exports) of Ireland in 2010 to that in 2011?
Give a very brief answer. 0.97. What is the ratio of the Cost of communications, computer etc. (% of service exports) in Thailand in 2010 to that in 2011?
Your response must be concise. 1.2. What is the ratio of the Cost of communications, computer etc. (% of service exports) of Belarus in 2010 to that in 2012?
Make the answer very short. 0.89. What is the ratio of the Cost of communications, computer etc. (% of service exports) of Ireland in 2010 to that in 2012?
Provide a short and direct response. 0.95. What is the ratio of the Cost of communications, computer etc. (% of service exports) in Thailand in 2010 to that in 2012?
Your answer should be very brief. 1.28. What is the ratio of the Cost of communications, computer etc. (% of service exports) in Belarus in 2010 to that in 2013?
Keep it short and to the point. 0.74. What is the ratio of the Cost of communications, computer etc. (% of service exports) of Ireland in 2010 to that in 2013?
Ensure brevity in your answer.  0.93. What is the ratio of the Cost of communications, computer etc. (% of service exports) in Thailand in 2010 to that in 2013?
Your answer should be very brief. 1.37. What is the ratio of the Cost of communications, computer etc. (% of service exports) of Belarus in 2011 to that in 2012?
Offer a terse response. 0.89. What is the ratio of the Cost of communications, computer etc. (% of service exports) of Ireland in 2011 to that in 2012?
Provide a short and direct response. 0.98. What is the ratio of the Cost of communications, computer etc. (% of service exports) of Thailand in 2011 to that in 2012?
Keep it short and to the point. 1.07. What is the ratio of the Cost of communications, computer etc. (% of service exports) of Belarus in 2011 to that in 2013?
Offer a very short reply. 0.74. What is the ratio of the Cost of communications, computer etc. (% of service exports) in Thailand in 2011 to that in 2013?
Keep it short and to the point. 1.14. What is the ratio of the Cost of communications, computer etc. (% of service exports) in Belarus in 2012 to that in 2013?
Offer a very short reply. 0.83. What is the ratio of the Cost of communications, computer etc. (% of service exports) of Ireland in 2012 to that in 2013?
Provide a succinct answer. 0.97. What is the ratio of the Cost of communications, computer etc. (% of service exports) in Thailand in 2012 to that in 2013?
Keep it short and to the point. 1.07. What is the difference between the highest and the second highest Cost of communications, computer etc. (% of service exports) in Belarus?
Provide a succinct answer. 6.46. What is the difference between the highest and the second highest Cost of communications, computer etc. (% of service exports) in Ireland?
Your answer should be very brief. 1.89. What is the difference between the highest and the second highest Cost of communications, computer etc. (% of service exports) in Thailand?
Provide a succinct answer. 3.96. What is the difference between the highest and the lowest Cost of communications, computer etc. (% of service exports) in Belarus?
Provide a short and direct response. 13.5. What is the difference between the highest and the lowest Cost of communications, computer etc. (% of service exports) in Ireland?
Make the answer very short. 18.06. What is the difference between the highest and the lowest Cost of communications, computer etc. (% of service exports) in Thailand?
Your response must be concise. 10.26. 